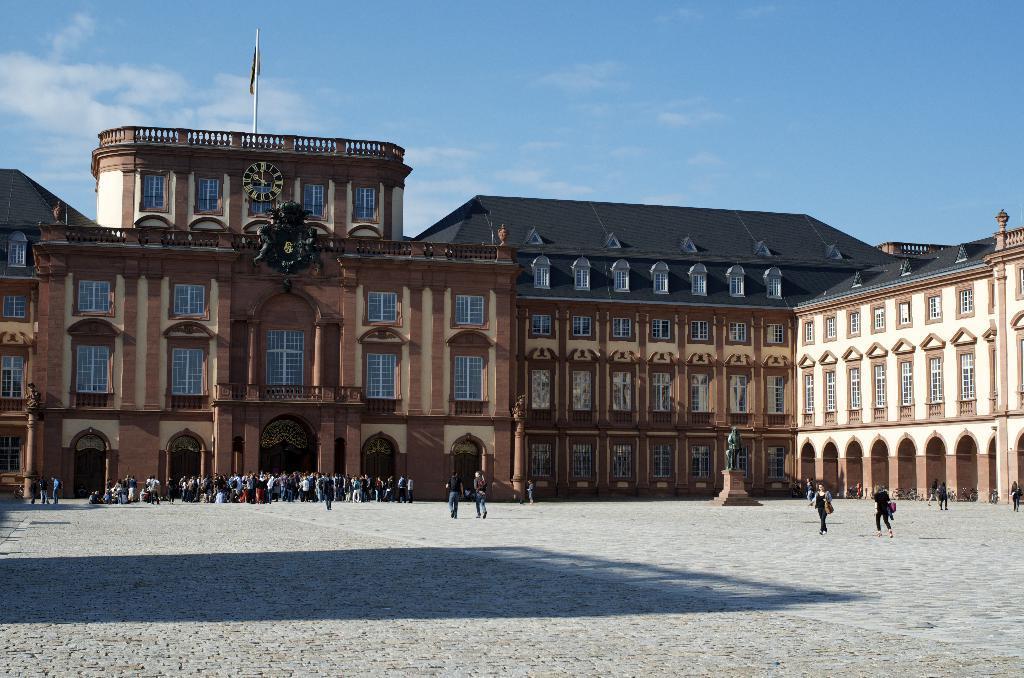Please provide a concise description of this image. In the picture we can see a building with windows and glasses to it and near to the building we can see a group of people standing on the path and on the top of the building we can see some part of the building with windows and railing and on top of it we can see a flag with a pole and behind it we can see a sky with clouds 